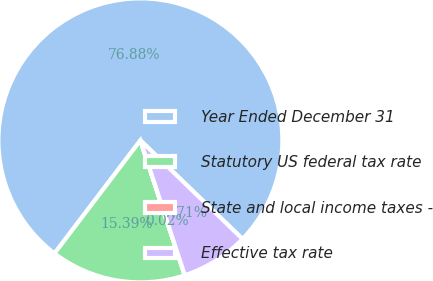Convert chart. <chart><loc_0><loc_0><loc_500><loc_500><pie_chart><fcel>Year Ended December 31<fcel>Statutory US federal tax rate<fcel>State and local income taxes -<fcel>Effective tax rate<nl><fcel>76.88%<fcel>15.39%<fcel>0.02%<fcel>7.71%<nl></chart> 